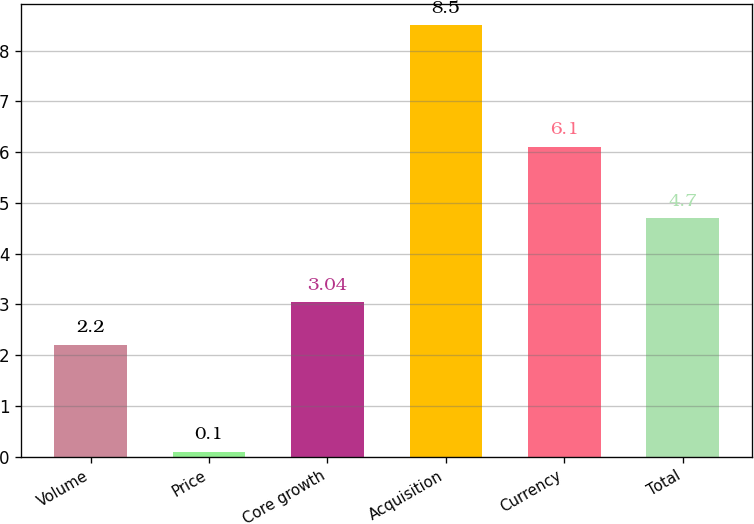Convert chart. <chart><loc_0><loc_0><loc_500><loc_500><bar_chart><fcel>Volume<fcel>Price<fcel>Core growth<fcel>Acquisition<fcel>Currency<fcel>Total<nl><fcel>2.2<fcel>0.1<fcel>3.04<fcel>8.5<fcel>6.1<fcel>4.7<nl></chart> 